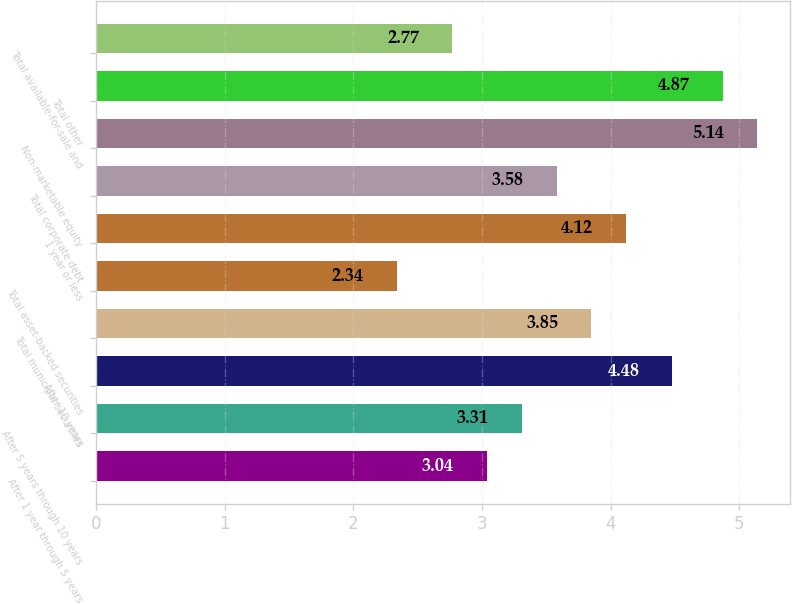Convert chart to OTSL. <chart><loc_0><loc_0><loc_500><loc_500><bar_chart><fcel>After 1 year through 5 years<fcel>After 5 years through 10 years<fcel>After 10 years<fcel>Total municipal securities<fcel>Total asset-backed securities<fcel>1 year or less<fcel>Total corporate debt<fcel>Non-marketable equity<fcel>Total other<fcel>Total available-for-sale and<nl><fcel>3.04<fcel>3.31<fcel>4.48<fcel>3.85<fcel>2.34<fcel>4.12<fcel>3.58<fcel>5.14<fcel>4.87<fcel>2.77<nl></chart> 